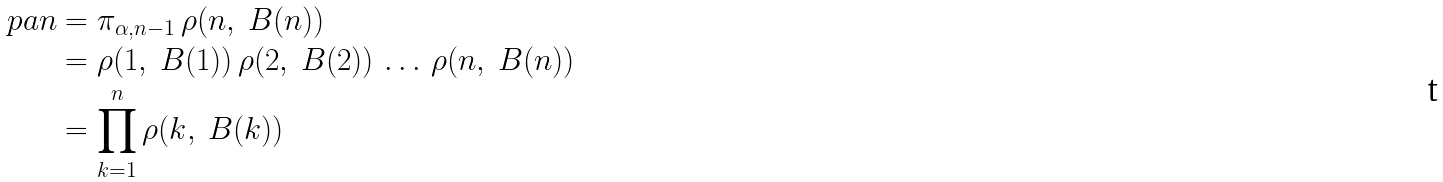<formula> <loc_0><loc_0><loc_500><loc_500>\ p a n & = \pi _ { \alpha , n - 1 } \, \rho ( n , \ B ( n ) ) \\ & = \rho ( 1 , \ B ( 1 ) ) \, \rho ( 2 , \ B ( 2 ) ) \, \dots \, \rho ( n , \ B ( n ) ) \\ & = \prod _ { k = 1 } ^ { n } \rho ( k , \ B ( k ) )</formula> 